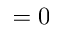Convert formula to latex. <formula><loc_0><loc_0><loc_500><loc_500>= 0</formula> 